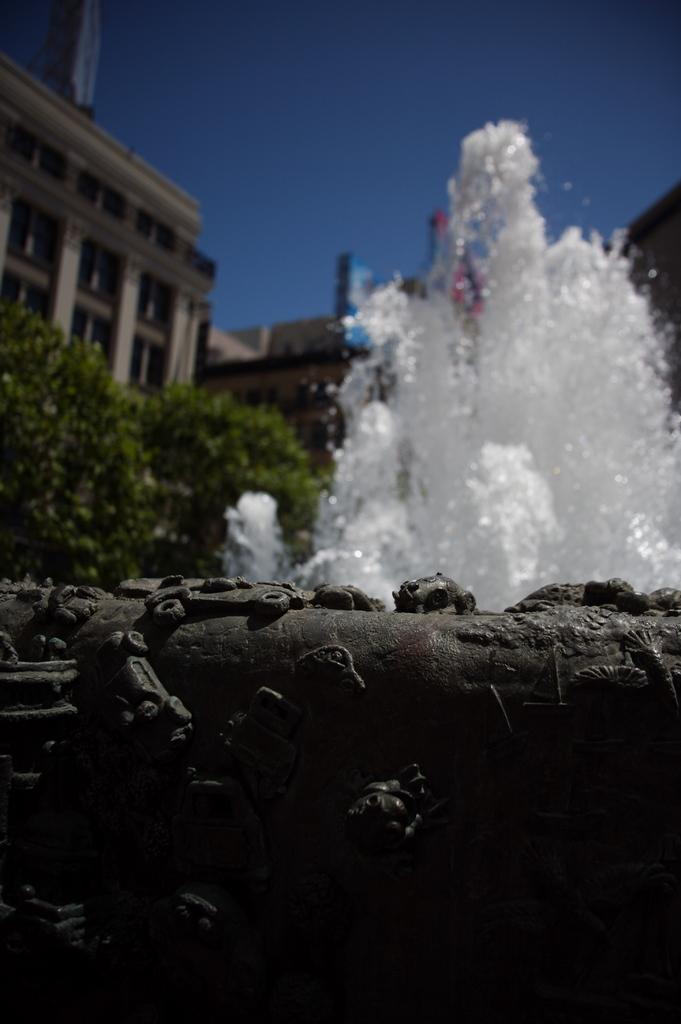What is the main feature in the image? There is a fountain in the image. What can be seen in the background of the image? There are trees, which are green, and buildings, which are cream and brown, in the background of the image. What color is the sky in the image? The sky is visible in the background of the image, and it is blue. Can you see a hose touching the fountain in the image? There is no hose present in the image, and therefore it cannot be touching the fountain. What type of brush is being used to paint the buildings in the image? There is no indication that the buildings are being painted or that a brush is being used in the image. 